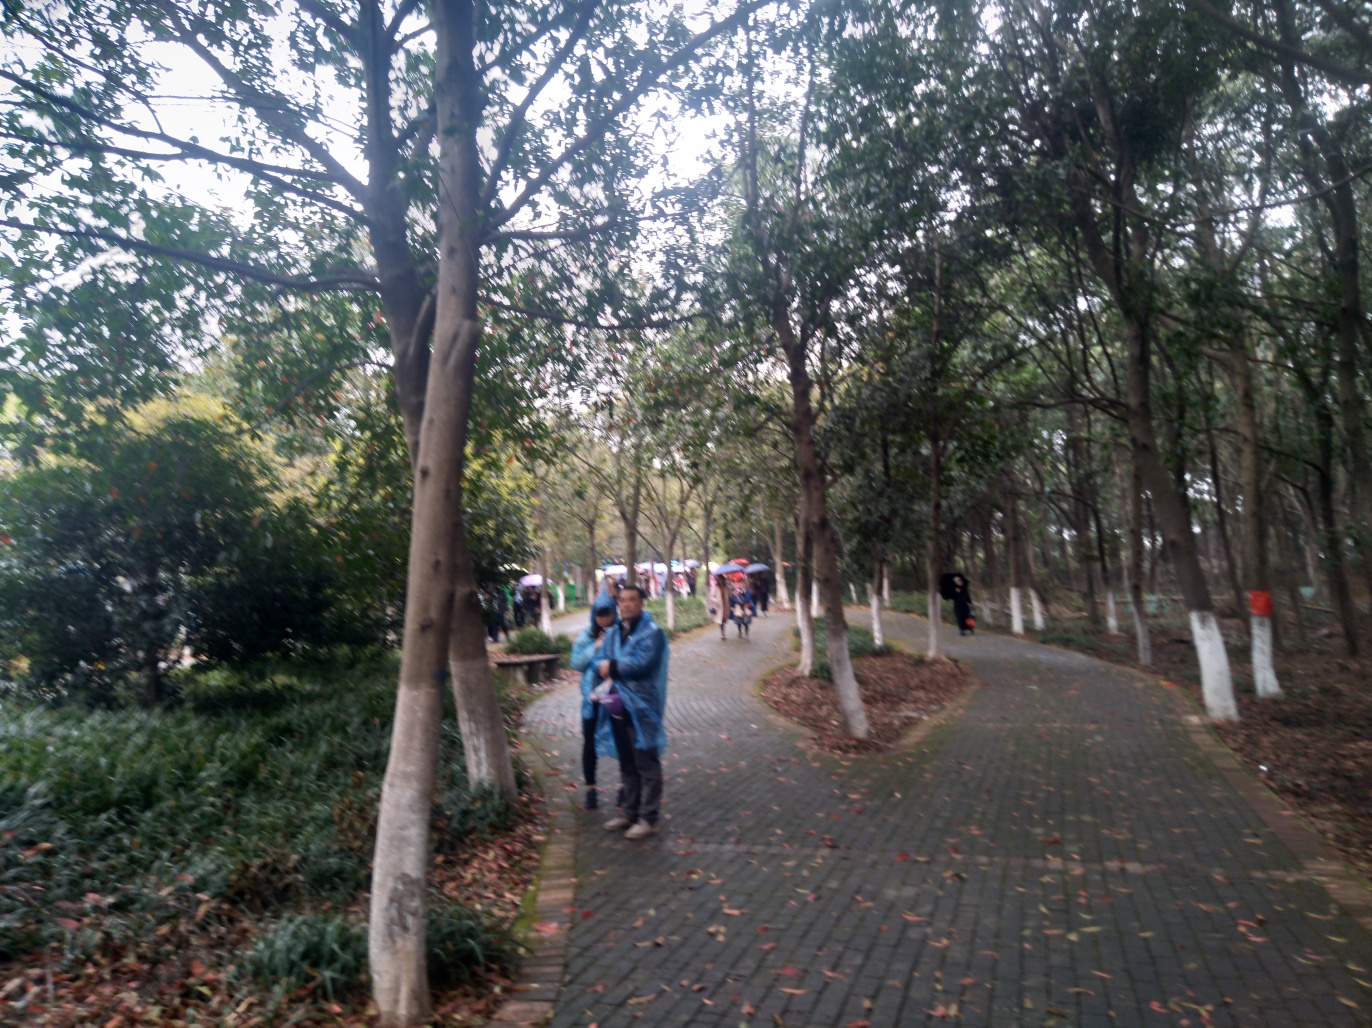Could you provide more details on the environment depicted in the image? Certainly! The image showcases an outdoor setting, likely a park or recreational area judging by the wide pathways and the natural landscaping. There are various species of trees and shrubs, which suggests that this area is well-maintained and possibly designed for leisurely walks or outdoor activities. The weather seems overcast, with no strong shadows indicating direct sunlight. There are individuals in the frame, enjoying a walk, which adds a calm and relaxed atmosphere to the scene. 